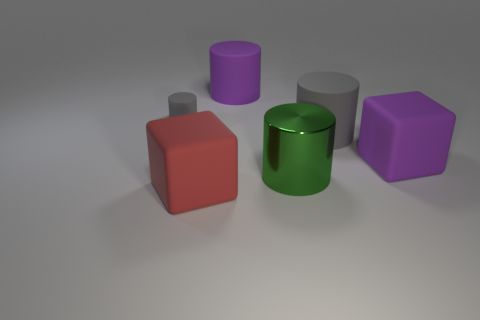Are there any big cylinders that have the same color as the small cylinder?
Your answer should be compact. Yes. Does the small cylinder have the same color as the big matte cylinder that is in front of the tiny rubber thing?
Give a very brief answer. Yes. The thing that is left of the big red rubber block that is in front of the large gray rubber object is what color?
Offer a very short reply. Gray. There is a big matte thing that is behind the gray rubber thing that is right of the tiny gray matte cylinder; are there any things that are on the right side of it?
Ensure brevity in your answer.  Yes. There is another tiny cylinder that is the same material as the purple cylinder; what color is it?
Your answer should be compact. Gray. How many purple things have the same material as the big green cylinder?
Provide a short and direct response. 0. Are the small gray thing and the big cube that is behind the big red rubber cube made of the same material?
Offer a very short reply. Yes. How many things are small gray cylinders behind the red block or large blue spheres?
Offer a terse response. 1. How big is the purple object that is to the left of the matte cylinder in front of the gray thing that is left of the red rubber thing?
Your answer should be compact. Large. There is a cylinder that is the same color as the tiny matte thing; what material is it?
Make the answer very short. Rubber. 